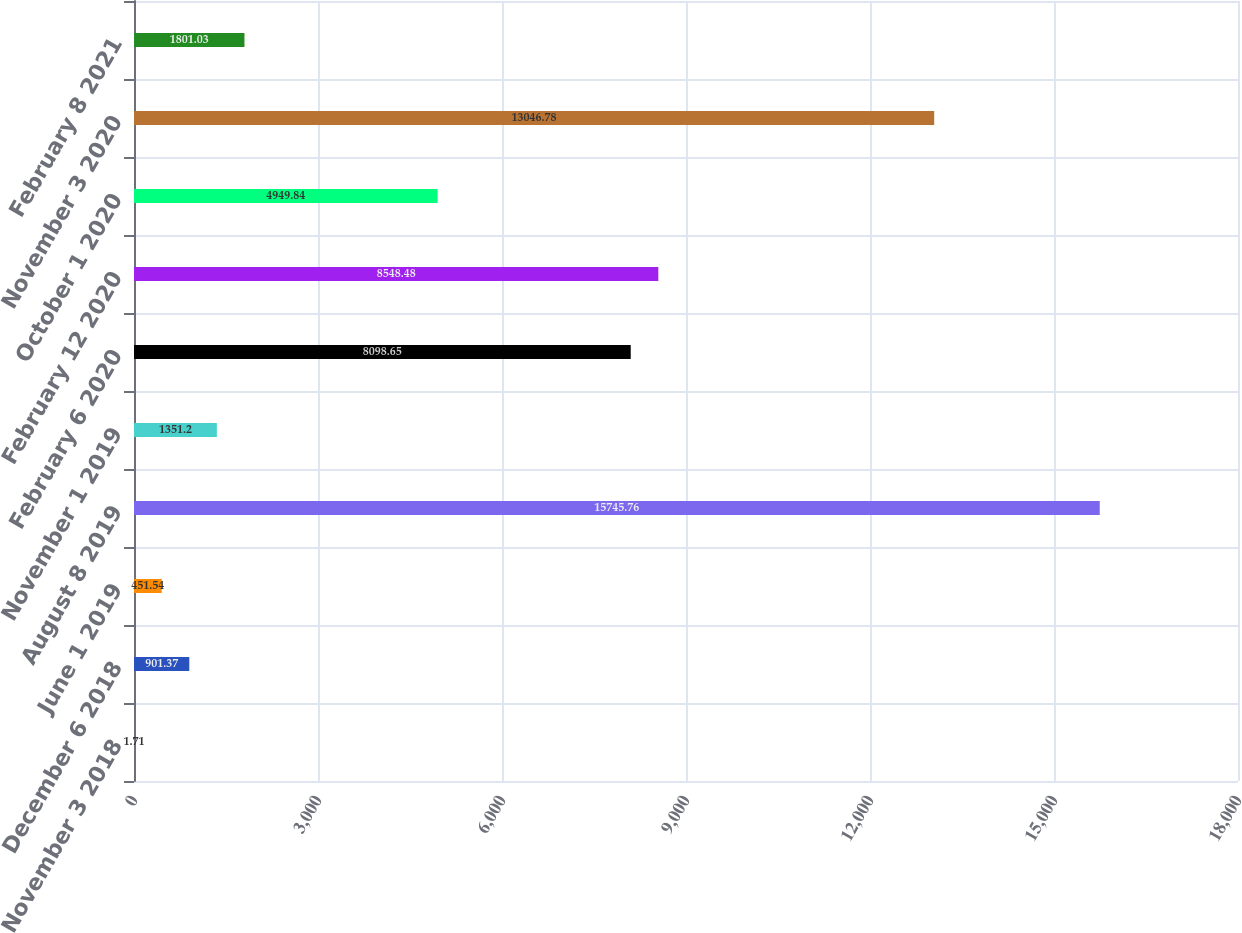Convert chart to OTSL. <chart><loc_0><loc_0><loc_500><loc_500><bar_chart><fcel>November 3 2018<fcel>December 6 2018<fcel>June 1 2019<fcel>August 8 2019<fcel>November 1 2019<fcel>February 6 2020<fcel>February 12 2020<fcel>October 1 2020<fcel>November 3 2020<fcel>February 8 2021<nl><fcel>1.71<fcel>901.37<fcel>451.54<fcel>15745.8<fcel>1351.2<fcel>8098.65<fcel>8548.48<fcel>4949.84<fcel>13046.8<fcel>1801.03<nl></chart> 